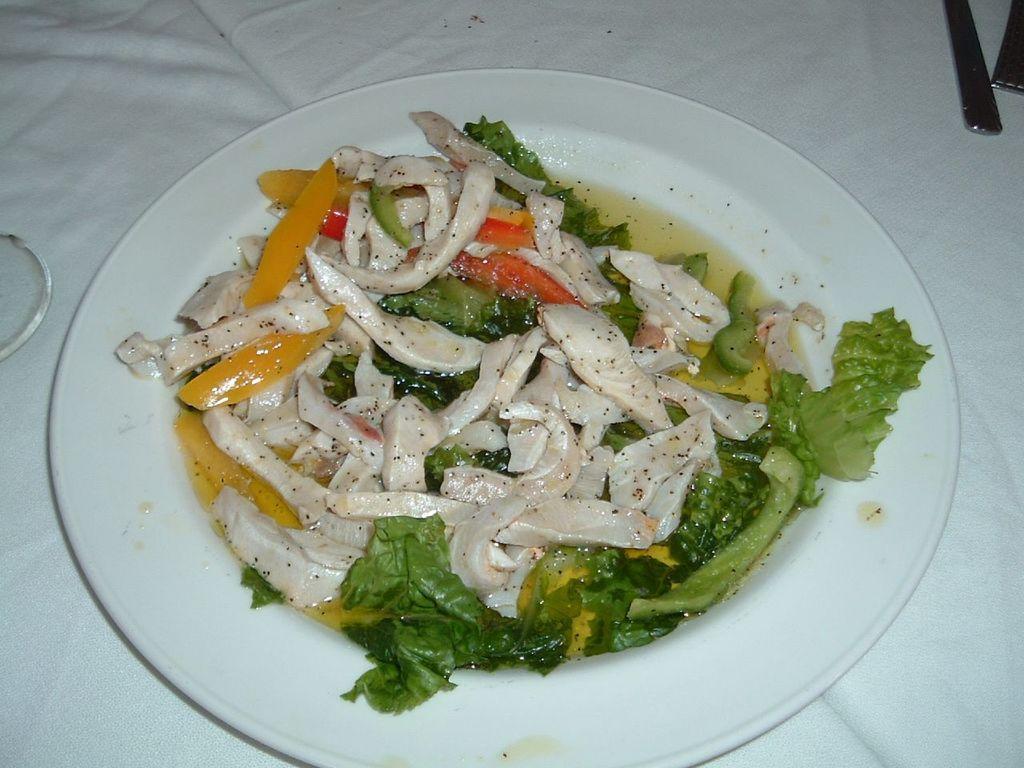What is on the plate that is visible in the image? There is food on a plate in the image. Besides the plate of food, what other items can be seen in the image? There are some objects in the image. Can you see a fly buzzing around the food on the plate in the image? There is no mention of a fly in the image, so it cannot be determined if one is present. Is there a locket hanging from the plate in the image? There is no mention of a locket in the image, so it cannot be determined if one is present. 